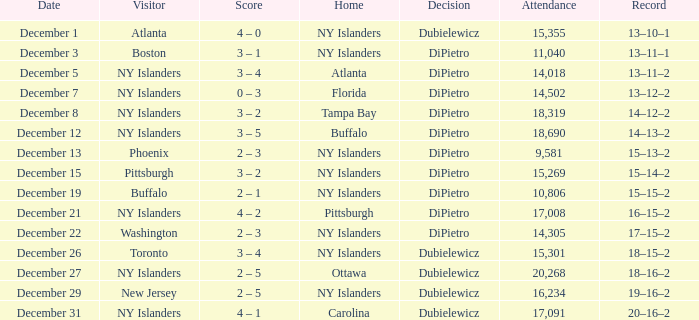Name the date for attendance more than 20,268 None. 